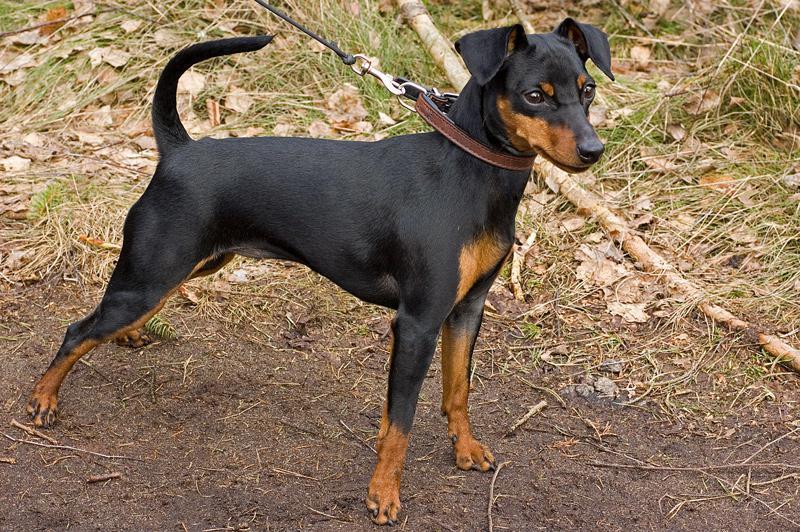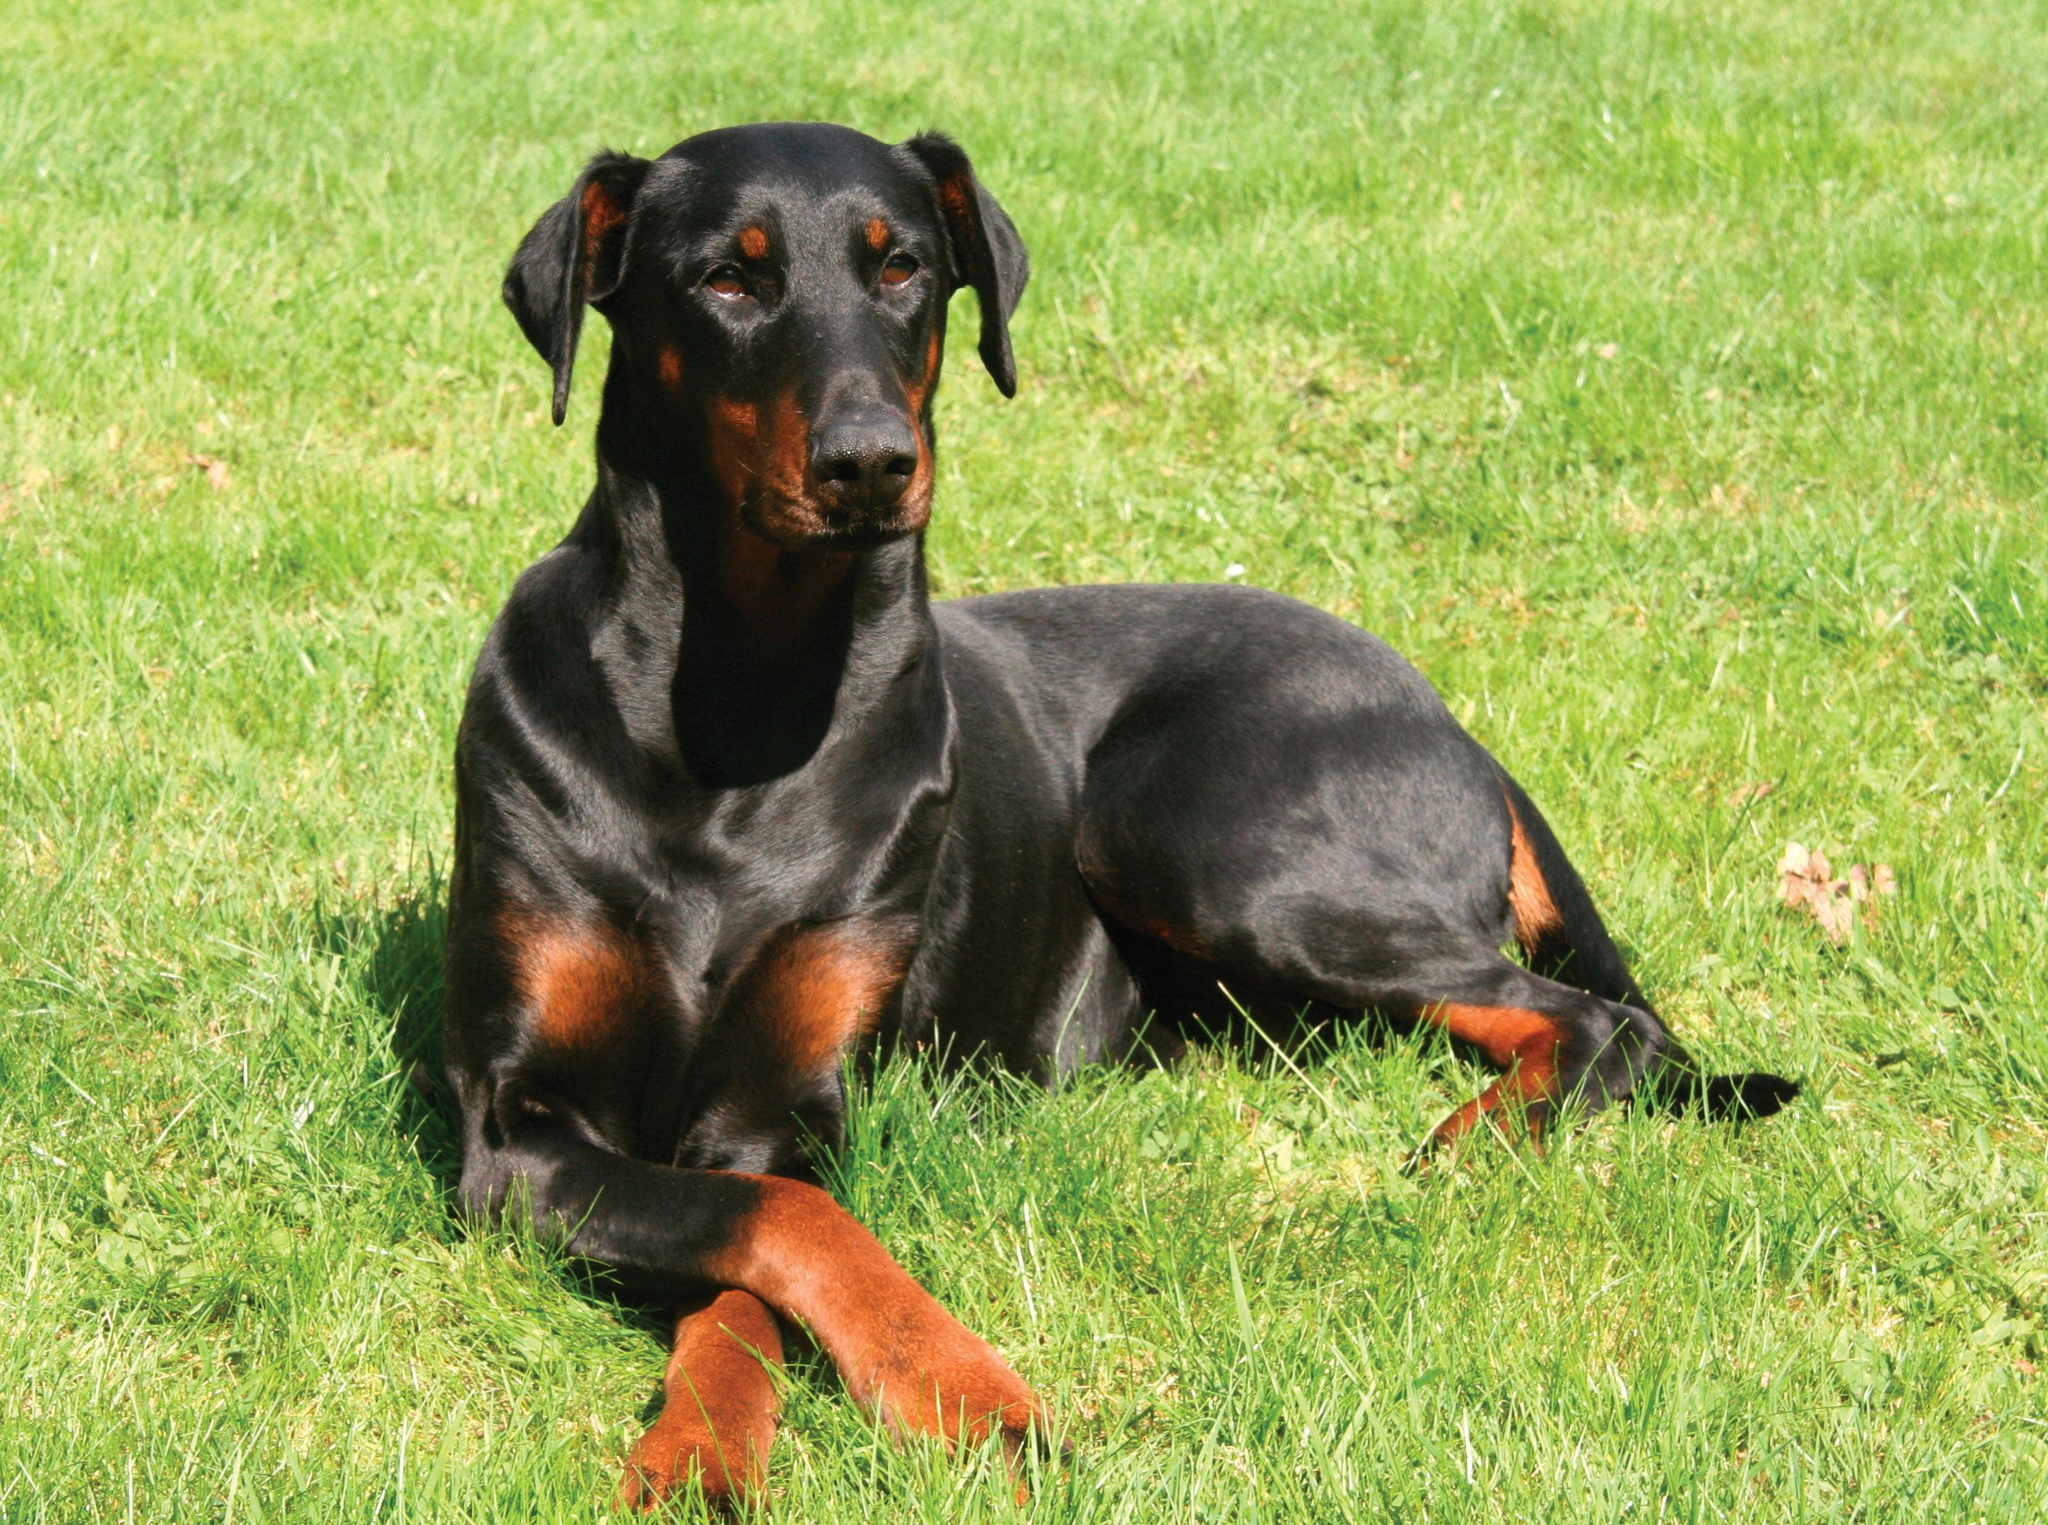The first image is the image on the left, the second image is the image on the right. Assess this claim about the two images: "tere is a dog sitting in the grass wearing a color and has pointy ears". Correct or not? Answer yes or no. No. The first image is the image on the left, the second image is the image on the right. Assess this claim about the two images: "The left image contains at least two dogs.". Correct or not? Answer yes or no. No. 